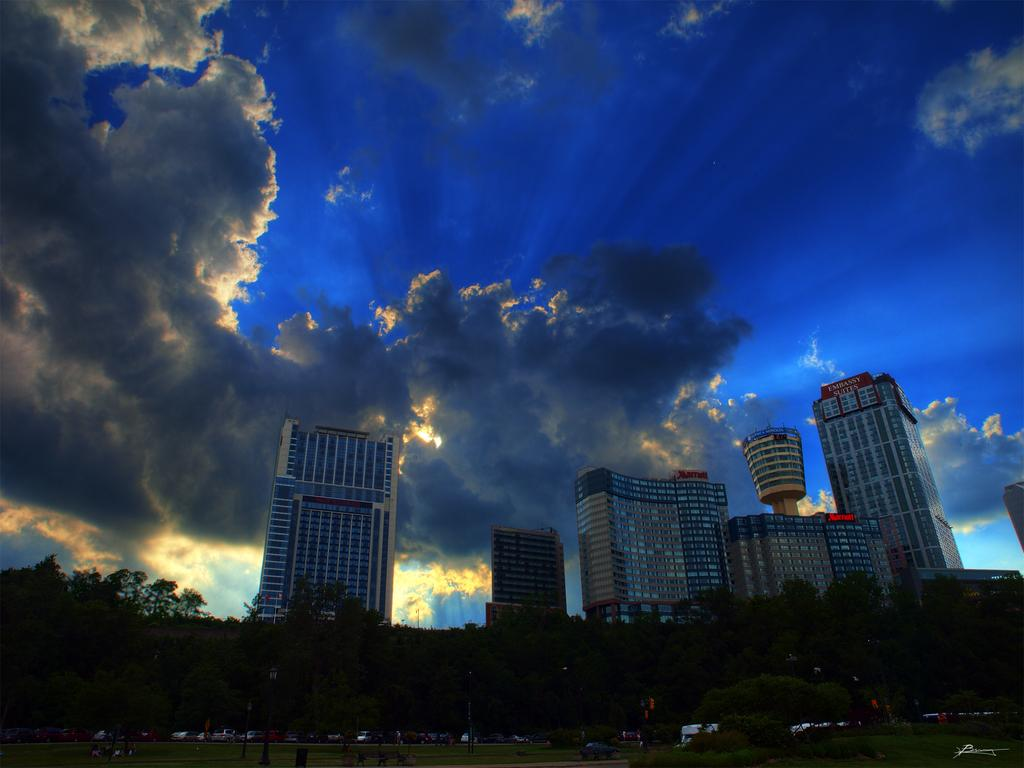What type of structures can be seen in the image? There are buildings in the image. What natural elements are present in the image? There are trees and grass in the image. What man-made objects can be seen in the image? There are vehicles in the image. What part of the natural environment is visible in the image? The sky is visible in the image. What atmospheric conditions can be observed in the sky? Clouds are present in the image. How would you describe the overall lighting in the image? The image appears to be slightly dark. What flavor of ghost can be seen in the image? There are no ghosts present in the image; it features buildings, trees, grass, vehicles, sky, and clouds. Can you tell me how many airports are visible in the image? There is no airport present in the image. 